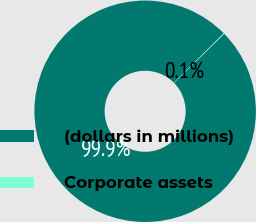Convert chart. <chart><loc_0><loc_0><loc_500><loc_500><pie_chart><fcel>(dollars in millions)<fcel>Corporate assets<nl><fcel>99.91%<fcel>0.09%<nl></chart> 